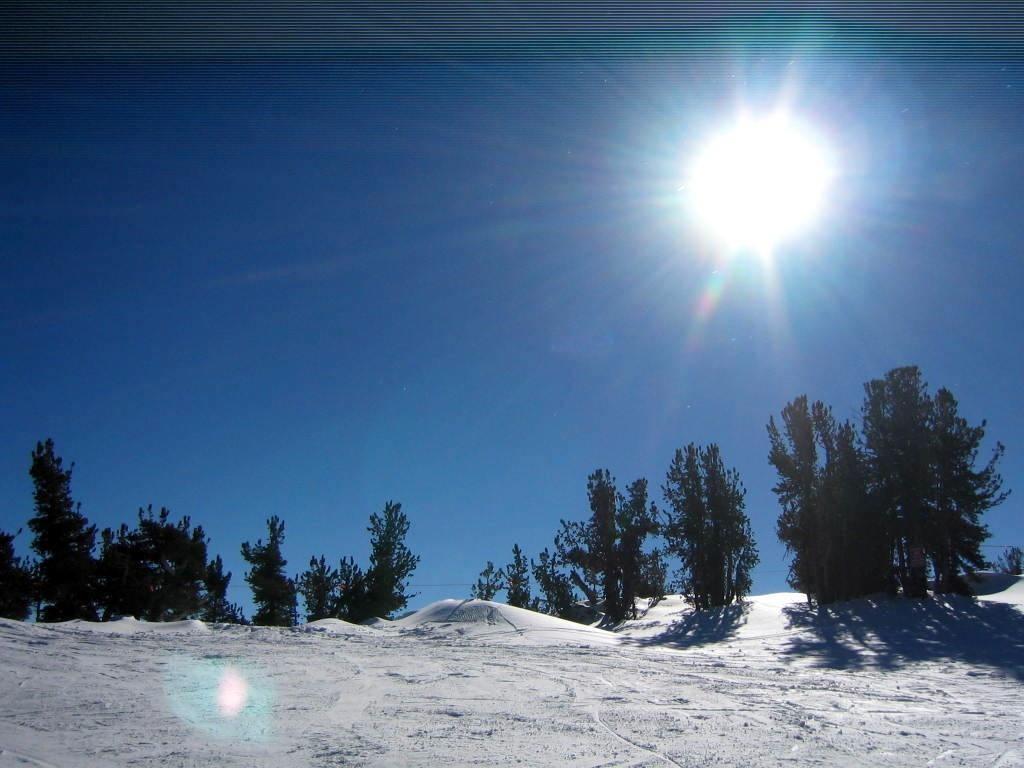Describe this image in one or two sentences. At the bottom this is the snow, these are the green trees in the middle of an image. On the right side its a sun in the sky. 